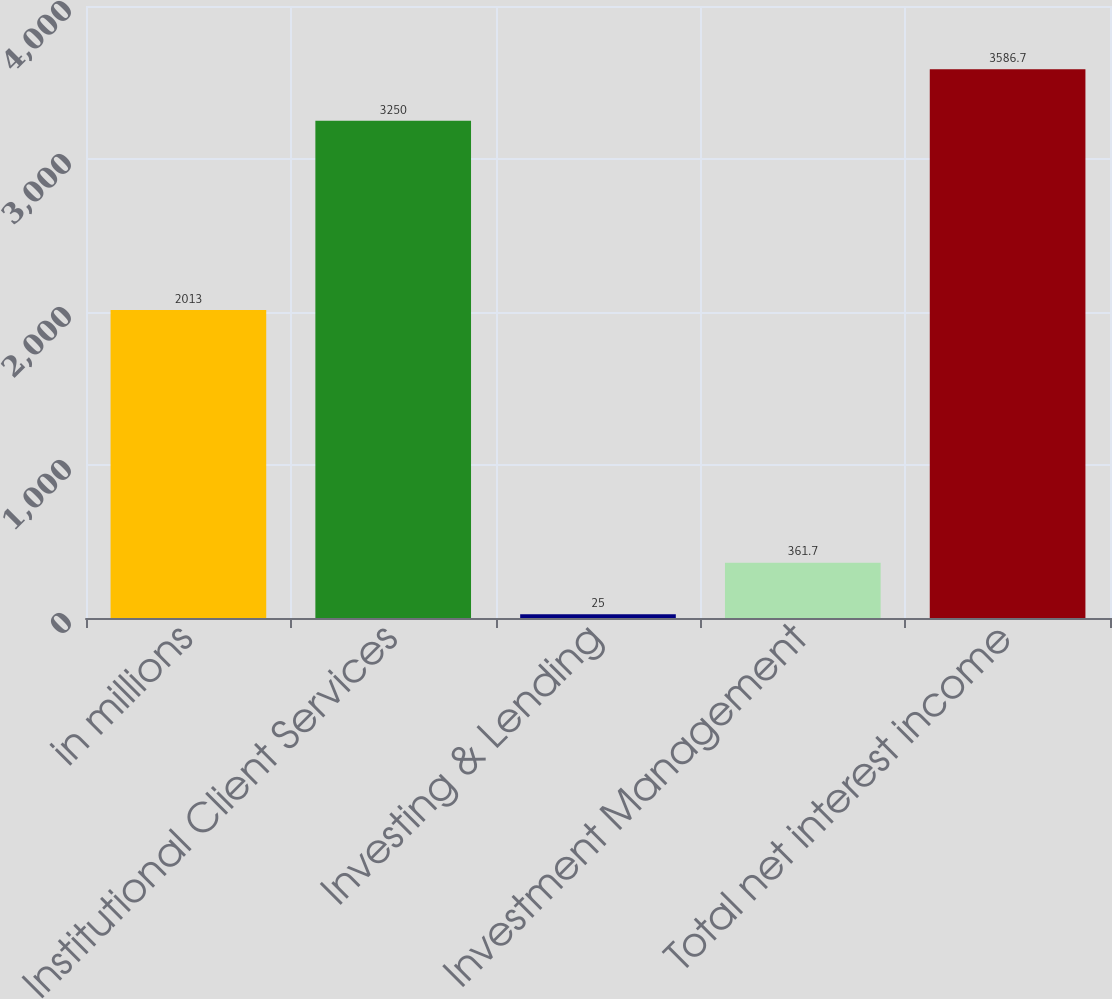<chart> <loc_0><loc_0><loc_500><loc_500><bar_chart><fcel>in millions<fcel>Institutional Client Services<fcel>Investing & Lending<fcel>Investment Management<fcel>Total net interest income<nl><fcel>2013<fcel>3250<fcel>25<fcel>361.7<fcel>3586.7<nl></chart> 